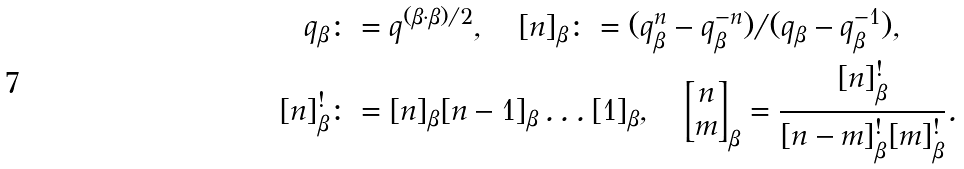<formula> <loc_0><loc_0><loc_500><loc_500>q _ { \beta } & \colon = q ^ { ( \beta \cdot \beta ) / 2 } , \quad [ n ] _ { \beta } \colon = ( q _ { \beta } ^ { n } - q _ { \beta } ^ { - n } ) / ( q _ { \beta } - q _ { \beta } ^ { - 1 } ) , \\ [ n ] ^ { ! } _ { \beta } & \colon = [ n ] _ { \beta } [ n - 1 ] _ { \beta } \dots [ 1 ] _ { \beta } , \quad \left [ \begin{matrix} n \\ m \end{matrix} \right ] _ { \beta } = \frac { [ n ] ^ { ! } _ { \beta } } { [ n - m ] ^ { ! } _ { \beta } [ m ] ^ { ! } _ { \beta } } .</formula> 